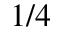<formula> <loc_0><loc_0><loc_500><loc_500>1 / 4</formula> 